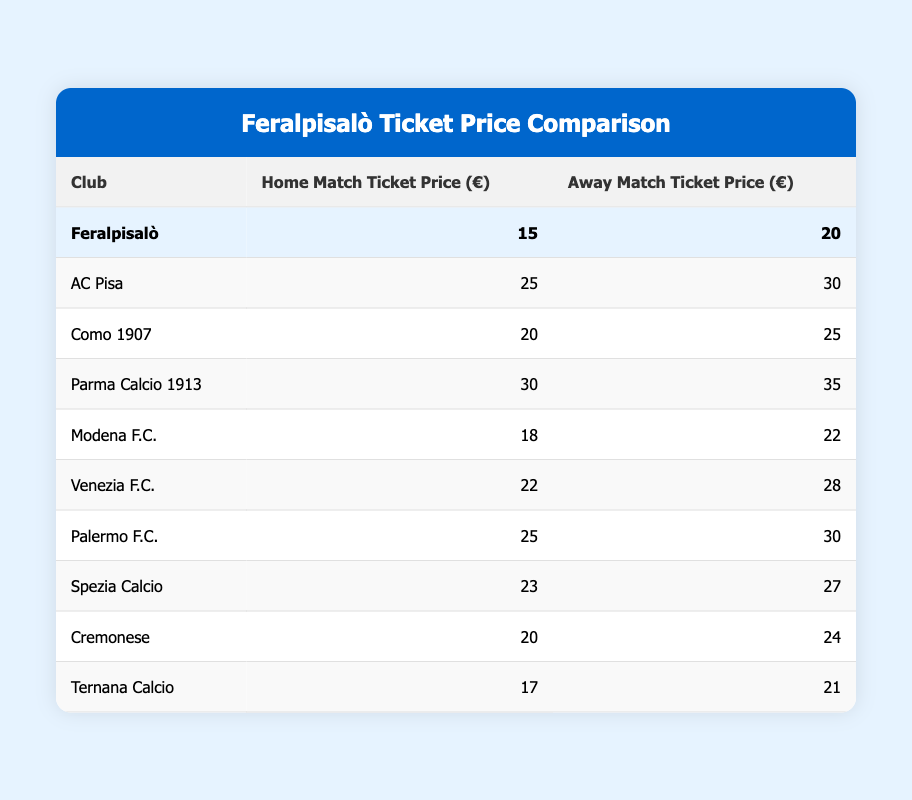What is the home match ticket price for Feralpisalò? The table lists the home match ticket price for Feralpisalò as 15 euros.
Answer: 15 What is the away match ticket price for AC Pisa? According to the table, AC Pisa's away match ticket price is 30 euros.
Answer: 30 Which club has the highest home match ticket price? By comparing the prices from the table, Parma Calcio 1913 has the highest home match ticket price of 30 euros.
Answer: Parma Calcio 1913 Is Feralpisalò's home match ticket price cheaper than Ternana Calcio's? Feralpisalò's home ticket price is 15 euros and Ternana Calcio's is 17 euros. Since 15 is less than 17, the statement is true.
Answer: Yes What is the average home match ticket price among all listed clubs? The home ticket prices are: 15, 25, 20, 30, 18, 22, 25, 23, 20, 17. Summing these gives 15 + 25 + 20 + 30 + 18 + 22 + 25 + 23 + 20 + 17 =  205. There are 10 clubs, so the average is 205/10 = 20.5.
Answer: 20.5 Which club has a lower away match ticket price: Venezia F.C. or Modena F.C.? Checking the table, Venezia F.C. has an away ticket price of 28 euros while Modena F.C. has 22 euros. Since 22 is less than 28, Modena F.C. has the lower price.
Answer: Modena F.C Are the away match ticket prices for Feralpisalò and Cremonese the same? The table shows Feralpisalò's away ticket price is 20 euros and Cremonese's is 24 euros, which means they are not the same.
Answer: No What is the difference in home match ticket prices between Feralpisalò and Palermo F.C.? The home price for Feralpisalò is 15 euros and for Palermo F.C. it's 25 euros. The difference is 25 - 15 = 10 euros.
Answer: 10 Which club has the least expensive away match ticket price? The away match ticket prices from the table indicate that Ternana Calcio has the least expensive at 21 euros.
Answer: Ternana Calcio 